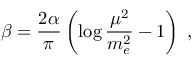<formula> <loc_0><loc_0><loc_500><loc_500>\beta = \frac { 2 \alpha } { \pi } \left ( \log \frac { \mu ^ { 2 } } { m _ { e } ^ { 2 } } - 1 \right ) \, ,</formula> 